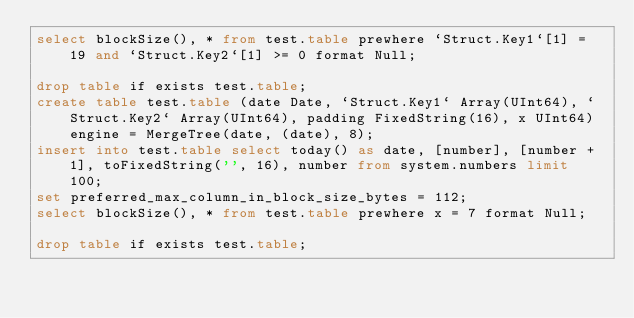Convert code to text. <code><loc_0><loc_0><loc_500><loc_500><_SQL_>select blockSize(), * from test.table prewhere `Struct.Key1`[1] = 19 and `Struct.Key2`[1] >= 0 format Null;

drop table if exists test.table;
create table test.table (date Date, `Struct.Key1` Array(UInt64), `Struct.Key2` Array(UInt64), padding FixedString(16), x UInt64) engine = MergeTree(date, (date), 8);
insert into test.table select today() as date, [number], [number + 1], toFixedString('', 16), number from system.numbers limit 100;
set preferred_max_column_in_block_size_bytes = 112;
select blockSize(), * from test.table prewhere x = 7 format Null;

drop table if exists test.table;
</code> 